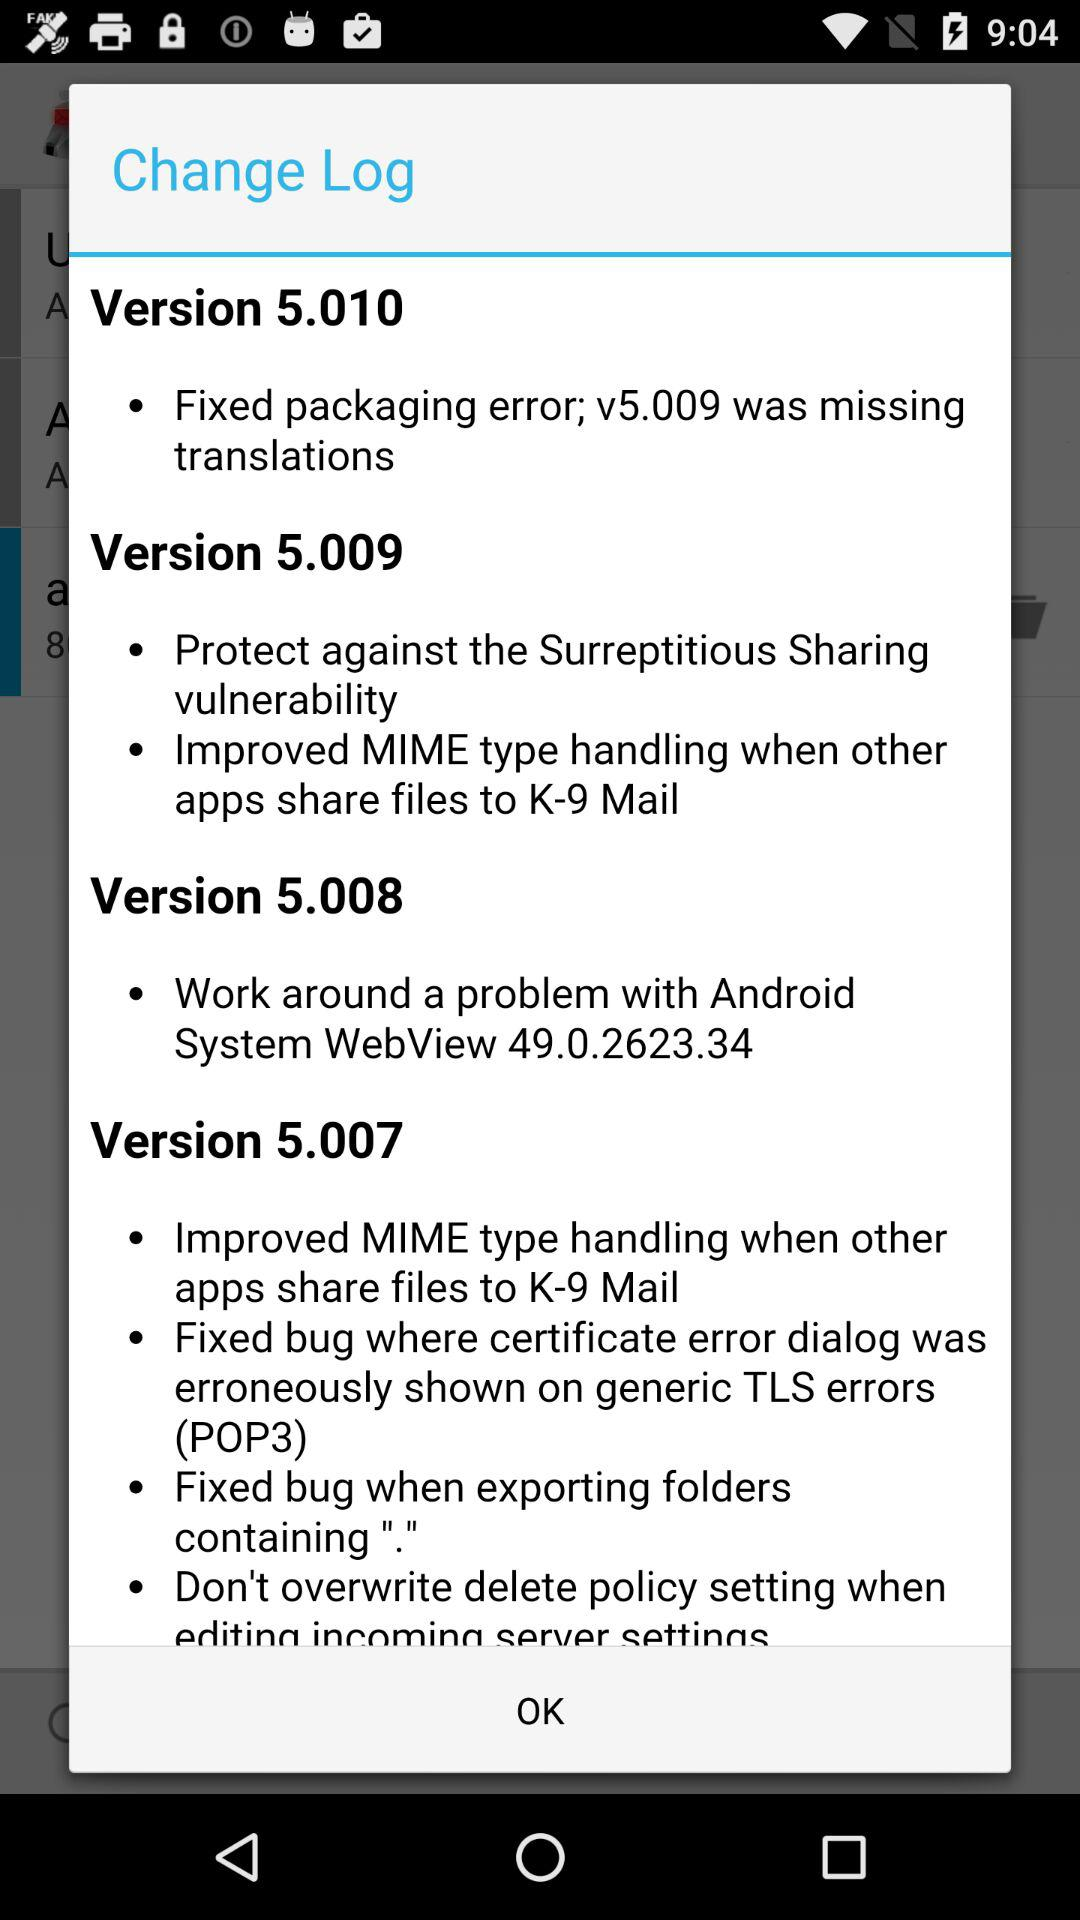What is the change log in version 5.008? The change log is "Work around a problem with Android System WebView 49.0.2623.34". 